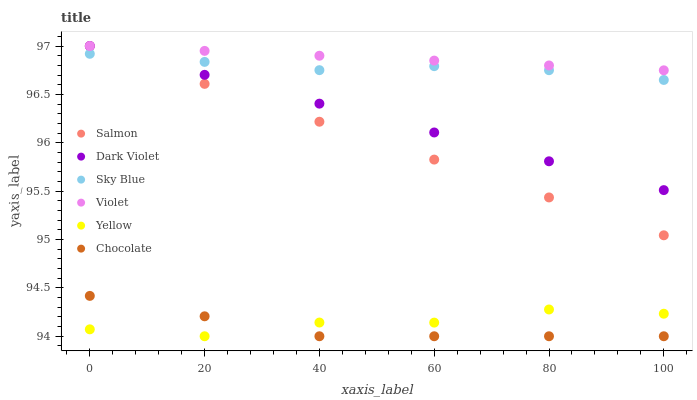Does Chocolate have the minimum area under the curve?
Answer yes or no. Yes. Does Violet have the maximum area under the curve?
Answer yes or no. Yes. Does Yellow have the minimum area under the curve?
Answer yes or no. No. Does Yellow have the maximum area under the curve?
Answer yes or no. No. Is Violet the smoothest?
Answer yes or no. Yes. Is Yellow the roughest?
Answer yes or no. Yes. Is Chocolate the smoothest?
Answer yes or no. No. Is Chocolate the roughest?
Answer yes or no. No. Does Yellow have the lowest value?
Answer yes or no. Yes. Does Dark Violet have the lowest value?
Answer yes or no. No. Does Violet have the highest value?
Answer yes or no. Yes. Does Chocolate have the highest value?
Answer yes or no. No. Is Chocolate less than Dark Violet?
Answer yes or no. Yes. Is Sky Blue greater than Chocolate?
Answer yes or no. Yes. Does Dark Violet intersect Violet?
Answer yes or no. Yes. Is Dark Violet less than Violet?
Answer yes or no. No. Is Dark Violet greater than Violet?
Answer yes or no. No. Does Chocolate intersect Dark Violet?
Answer yes or no. No. 